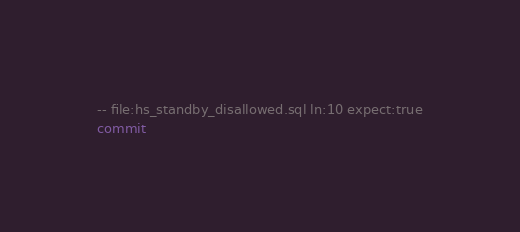<code> <loc_0><loc_0><loc_500><loc_500><_SQL_>-- file:hs_standby_disallowed.sql ln:10 expect:true
commit
</code> 